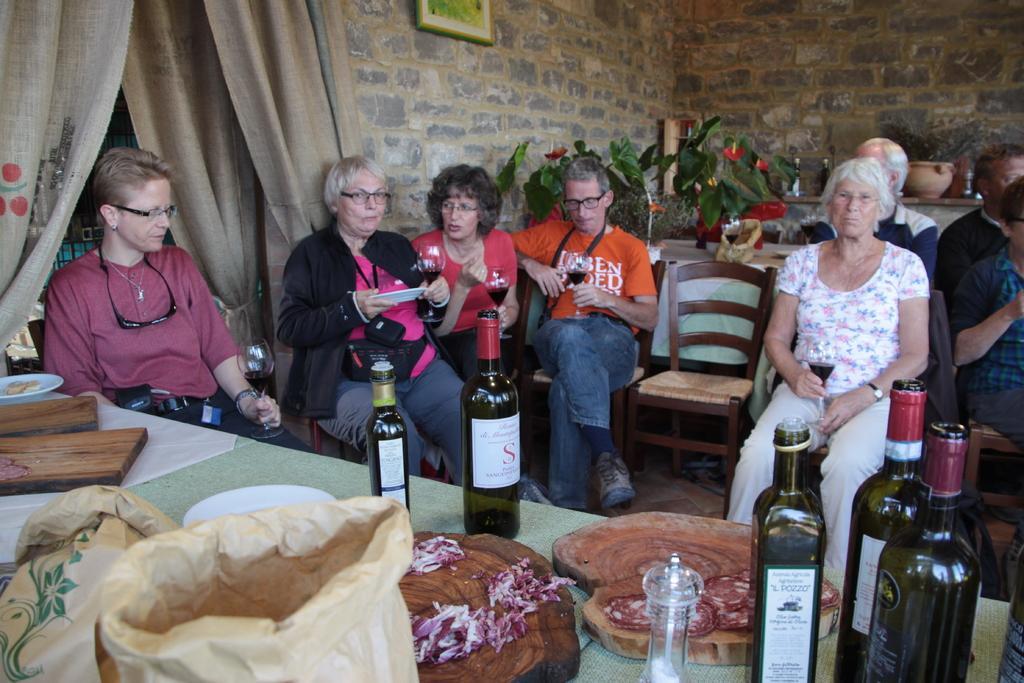In one or two sentences, can you explain what this image depicts? In this image I can see a group of people are sitting on the chair and holding wine glasses in there hands. On the table we have a few bottle and other objects on it. On the left side of the image we have a curtain and behind these people we have plants and a wall of stone. 